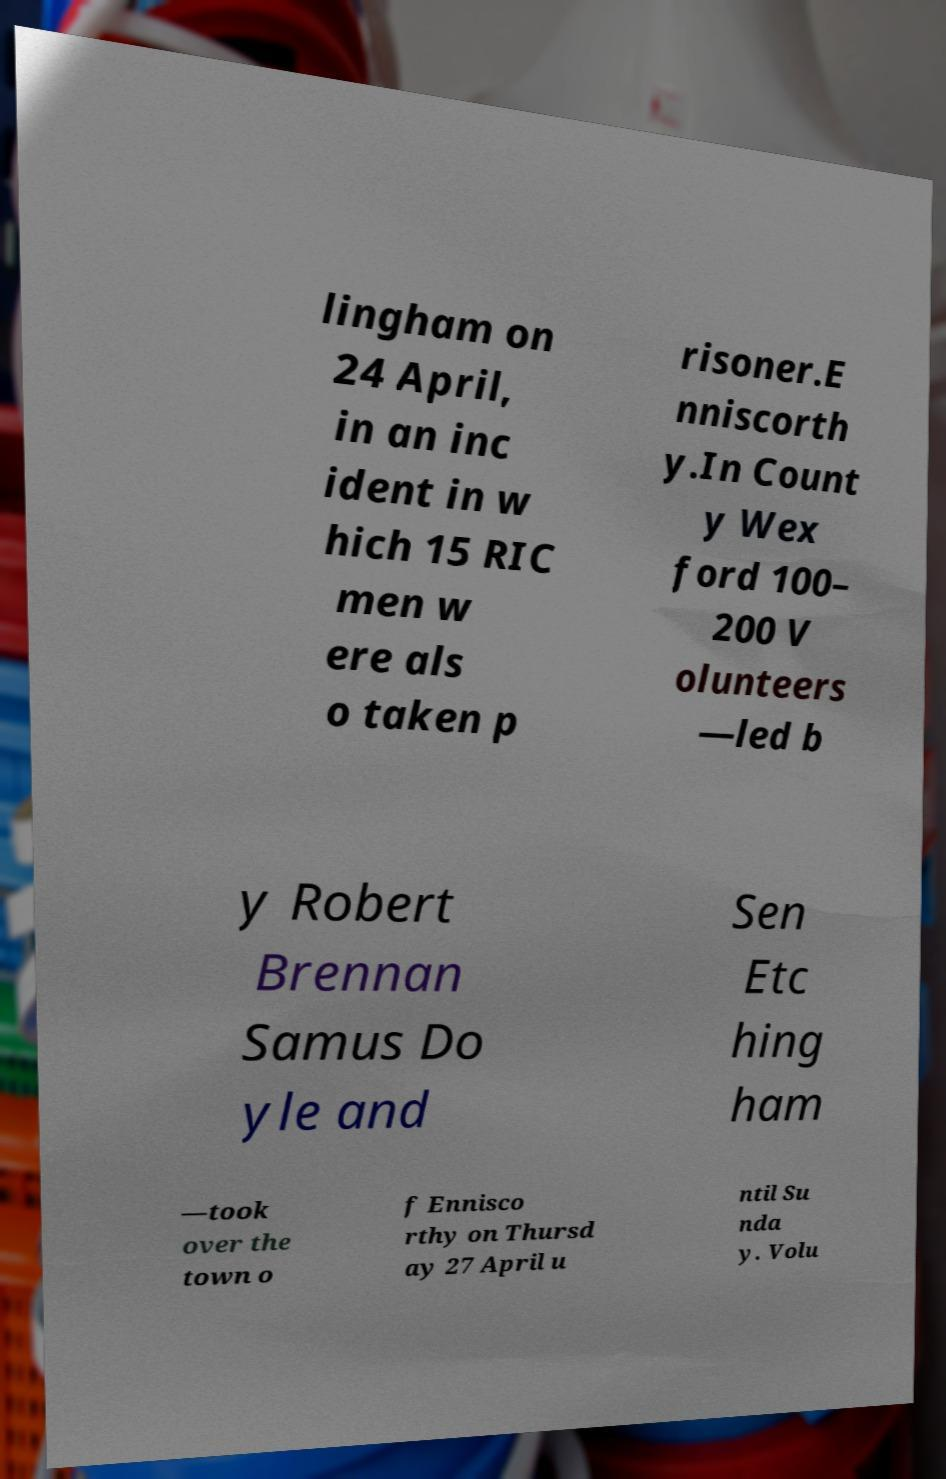What messages or text are displayed in this image? I need them in a readable, typed format. lingham on 24 April, in an inc ident in w hich 15 RIC men w ere als o taken p risoner.E nniscorth y.In Count y Wex ford 100– 200 V olunteers —led b y Robert Brennan Samus Do yle and Sen Etc hing ham —took over the town o f Ennisco rthy on Thursd ay 27 April u ntil Su nda y. Volu 